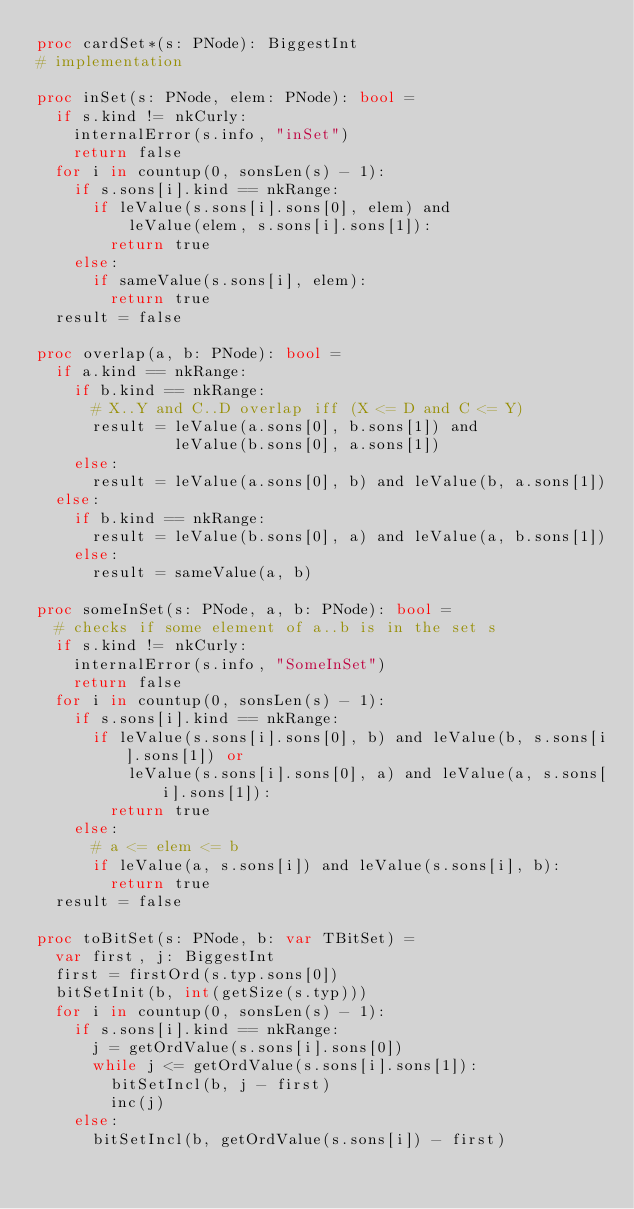<code> <loc_0><loc_0><loc_500><loc_500><_Nim_>proc cardSet*(s: PNode): BiggestInt
# implementation

proc inSet(s: PNode, elem: PNode): bool = 
  if s.kind != nkCurly: 
    internalError(s.info, "inSet")
    return false
  for i in countup(0, sonsLen(s) - 1): 
    if s.sons[i].kind == nkRange: 
      if leValue(s.sons[i].sons[0], elem) and
          leValue(elem, s.sons[i].sons[1]): 
        return true
    else: 
      if sameValue(s.sons[i], elem): 
        return true
  result = false

proc overlap(a, b: PNode): bool =
  if a.kind == nkRange:
    if b.kind == nkRange:
      # X..Y and C..D overlap iff (X <= D and C <= Y)
      result = leValue(a.sons[0], b.sons[1]) and
               leValue(b.sons[0], a.sons[1])
    else:
      result = leValue(a.sons[0], b) and leValue(b, a.sons[1])
  else:
    if b.kind == nkRange:
      result = leValue(b.sons[0], a) and leValue(a, b.sons[1])
    else:
      result = sameValue(a, b)

proc someInSet(s: PNode, a, b: PNode): bool = 
  # checks if some element of a..b is in the set s
  if s.kind != nkCurly:
    internalError(s.info, "SomeInSet")
    return false
  for i in countup(0, sonsLen(s) - 1): 
    if s.sons[i].kind == nkRange: 
      if leValue(s.sons[i].sons[0], b) and leValue(b, s.sons[i].sons[1]) or
          leValue(s.sons[i].sons[0], a) and leValue(a, s.sons[i].sons[1]): 
        return true
    else: 
      # a <= elem <= b
      if leValue(a, s.sons[i]) and leValue(s.sons[i], b): 
        return true
  result = false

proc toBitSet(s: PNode, b: var TBitSet) = 
  var first, j: BiggestInt
  first = firstOrd(s.typ.sons[0])
  bitSetInit(b, int(getSize(s.typ)))
  for i in countup(0, sonsLen(s) - 1): 
    if s.sons[i].kind == nkRange: 
      j = getOrdValue(s.sons[i].sons[0])
      while j <= getOrdValue(s.sons[i].sons[1]): 
        bitSetIncl(b, j - first)
        inc(j)
    else: 
      bitSetIncl(b, getOrdValue(s.sons[i]) - first)
  </code> 